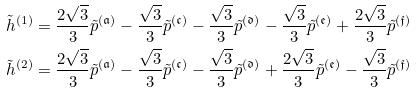<formula> <loc_0><loc_0><loc_500><loc_500>\tilde { h } ^ { ( 1 ) } & = \frac { 2 \sqrt { 3 } } { 3 } \tilde { p } ^ { ( \mathfrak { a } ) } - \frac { \sqrt { 3 } } { 3 } \tilde { p } ^ { ( \mathfrak { c } ) } - \frac { \sqrt { 3 } } { 3 } \tilde { p } ^ { ( \mathfrak { d } ) } - \frac { \sqrt { 3 } } { 3 } \tilde { p } ^ { ( \mathfrak { e } ) } + \frac { 2 \sqrt { 3 } } { 3 } \tilde { p } ^ { ( \mathfrak { f } ) } \\ \tilde { h } ^ { ( 2 ) } & = \frac { 2 \sqrt { 3 } } { 3 } \tilde { p } ^ { ( \mathfrak { a } ) } - \frac { \sqrt { 3 } } { 3 } \tilde { p } ^ { ( \mathfrak { c } ) } - \frac { \sqrt { 3 } } { 3 } \tilde { p } ^ { ( \mathfrak { d } ) } + \frac { 2 \sqrt { 3 } } { 3 } \tilde { p } ^ { ( \mathfrak { e } ) } - \frac { \sqrt { 3 } } { 3 } \tilde { p } ^ { ( \mathfrak { f } ) }</formula> 